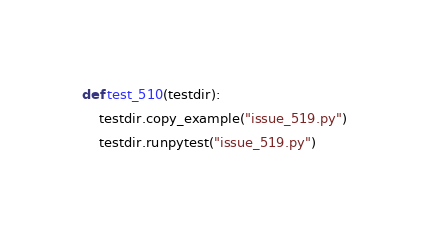<code> <loc_0><loc_0><loc_500><loc_500><_Python_>def test_510(testdir):
    testdir.copy_example("issue_519.py")
    testdir.runpytest("issue_519.py")
</code> 